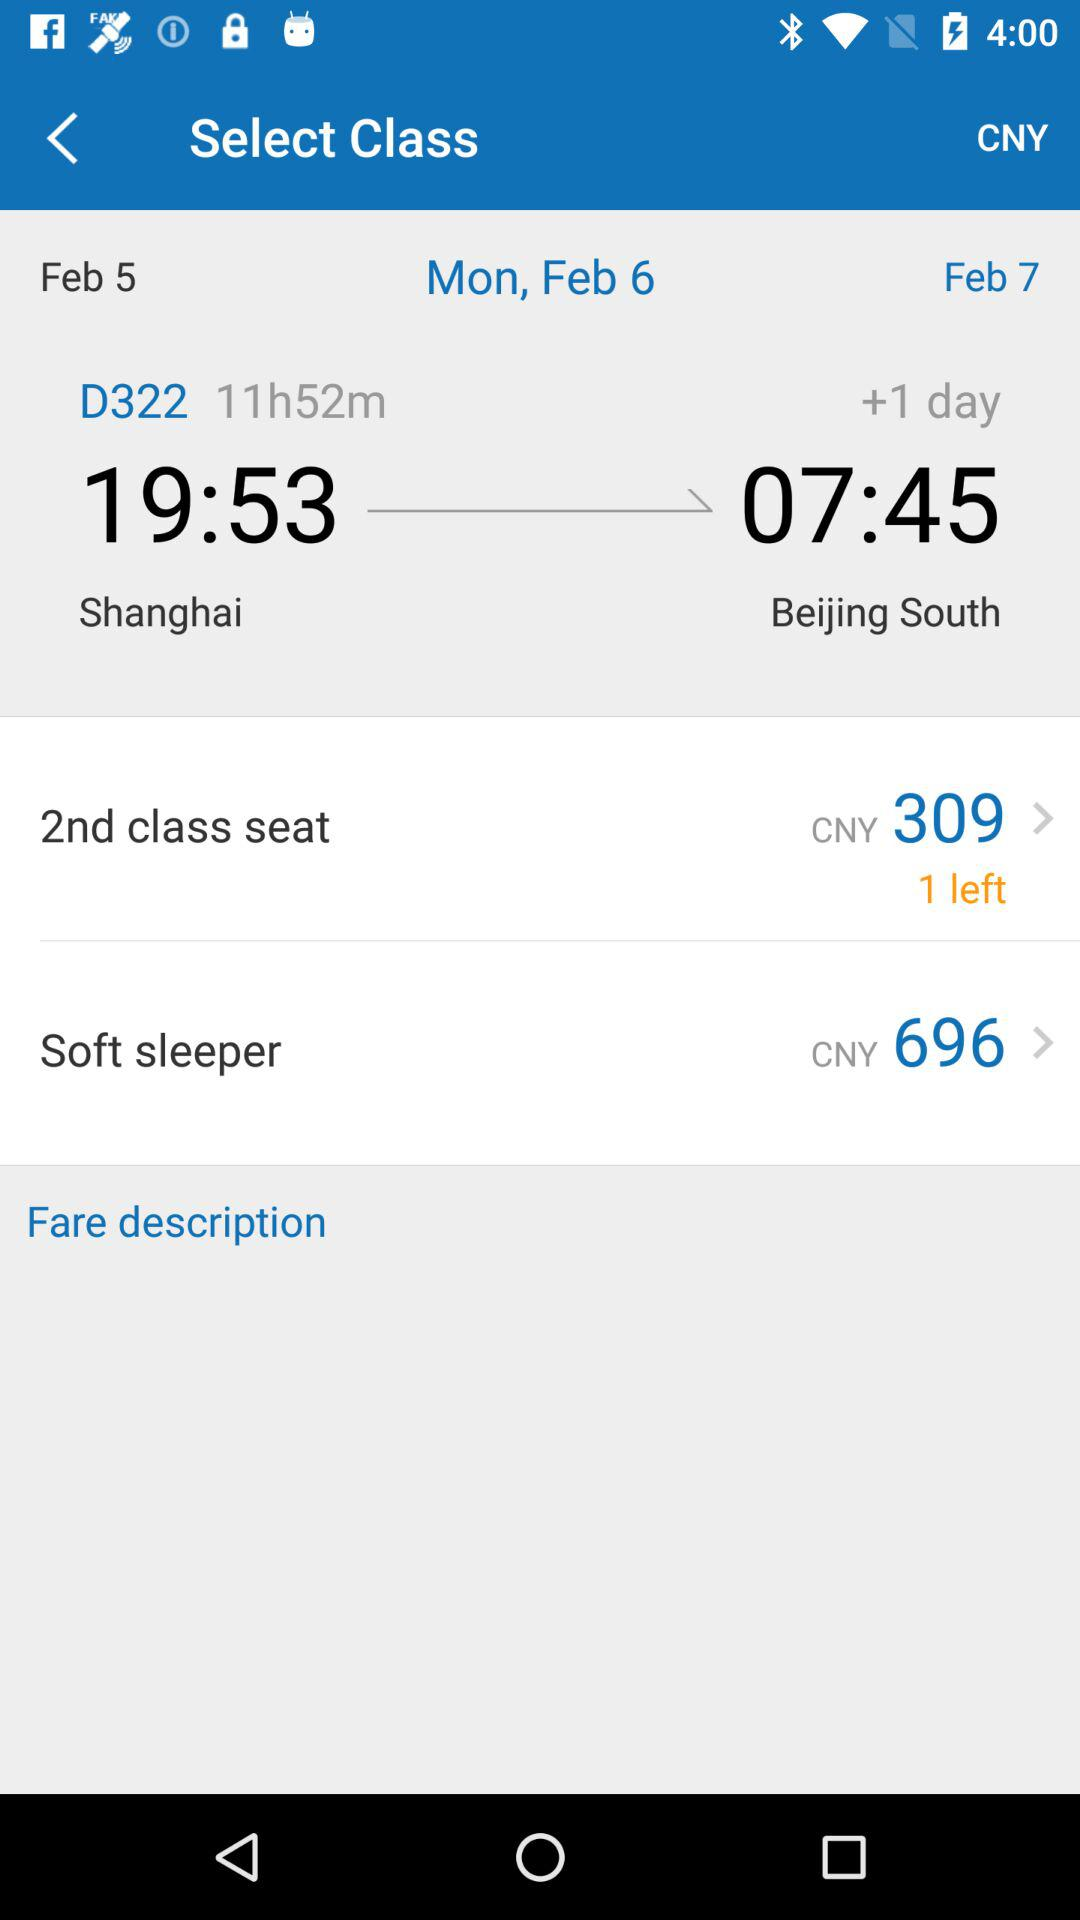What is the departure date of the journey? The departure date is Monday, February 6. 